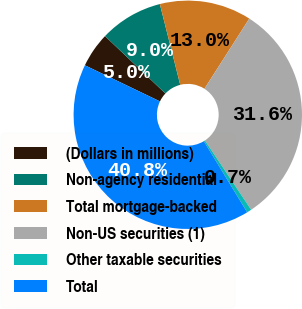<chart> <loc_0><loc_0><loc_500><loc_500><pie_chart><fcel>(Dollars in millions)<fcel>Non-agency residential<fcel>Total mortgage-backed<fcel>Non-US securities (1)<fcel>Other taxable securities<fcel>Total<nl><fcel>4.96%<fcel>8.97%<fcel>12.99%<fcel>31.58%<fcel>0.66%<fcel>40.84%<nl></chart> 